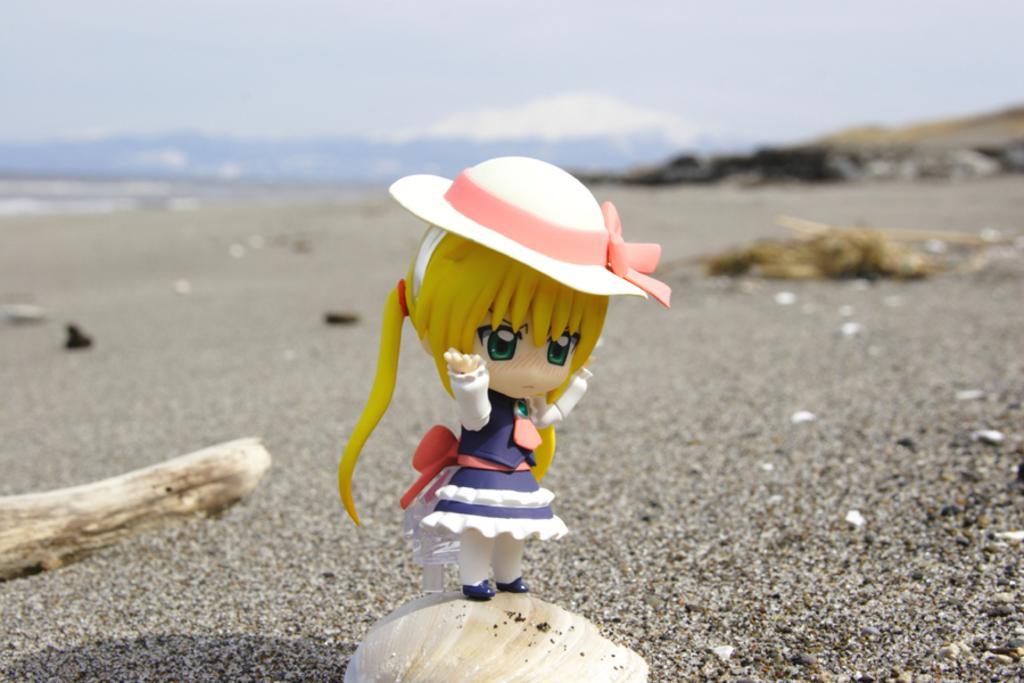In one or two sentences, can you explain what this image depicts? In this image in the center there is one toy and at the bottom there is sand, wooden stick and in the background there are some mountains at the top of the image there is sky and at the bottom there is a shell. 